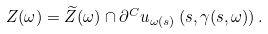Convert formula to latex. <formula><loc_0><loc_0><loc_500><loc_500>Z ( \omega ) = \widetilde { Z } ( \omega ) \cap \partial ^ { C } u _ { \omega ( s ) } \left ( s , \gamma ( s , \omega ) \right ) .</formula> 